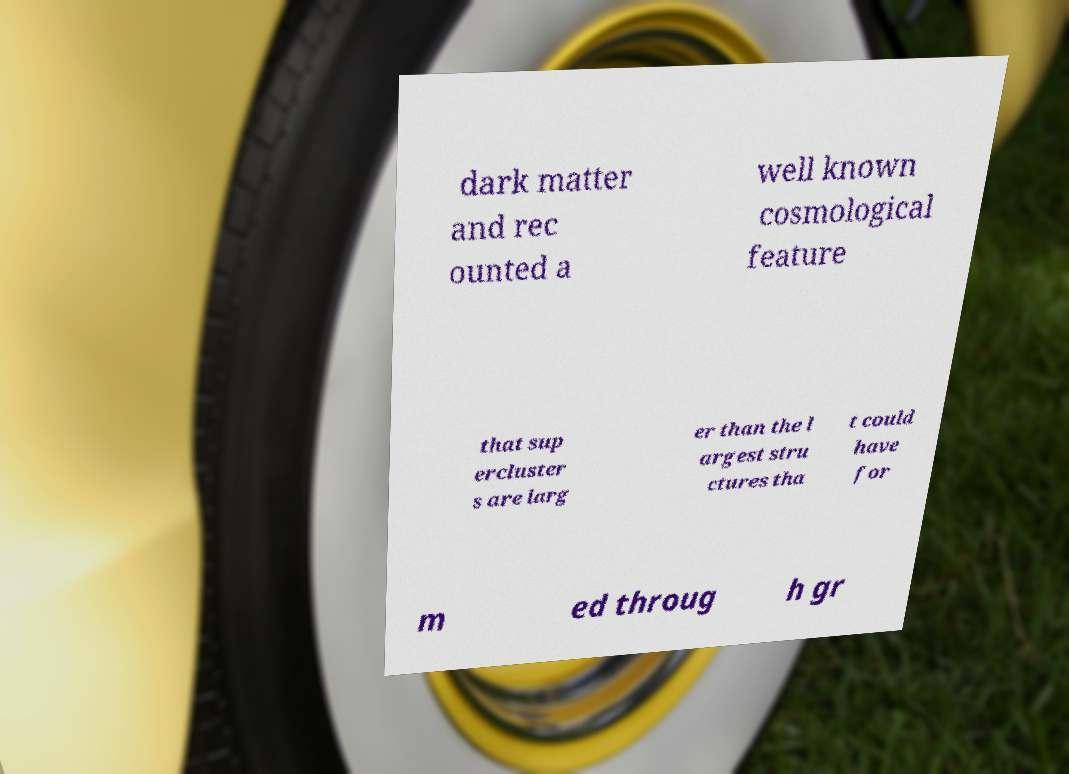For documentation purposes, I need the text within this image transcribed. Could you provide that? dark matter and rec ounted a well known cosmological feature that sup ercluster s are larg er than the l argest stru ctures tha t could have for m ed throug h gr 